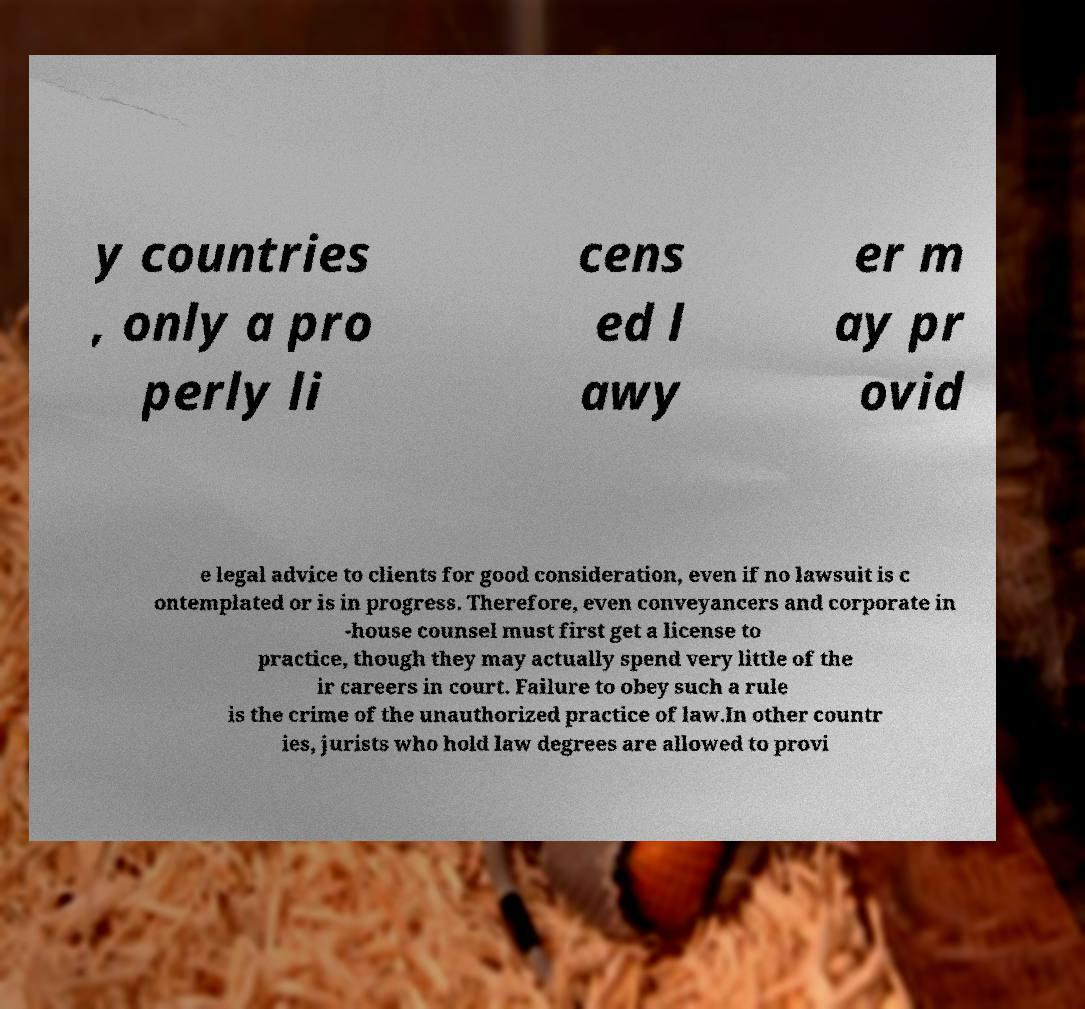What messages or text are displayed in this image? I need them in a readable, typed format. y countries , only a pro perly li cens ed l awy er m ay pr ovid e legal advice to clients for good consideration, even if no lawsuit is c ontemplated or is in progress. Therefore, even conveyancers and corporate in -house counsel must first get a license to practice, though they may actually spend very little of the ir careers in court. Failure to obey such a rule is the crime of the unauthorized practice of law.In other countr ies, jurists who hold law degrees are allowed to provi 